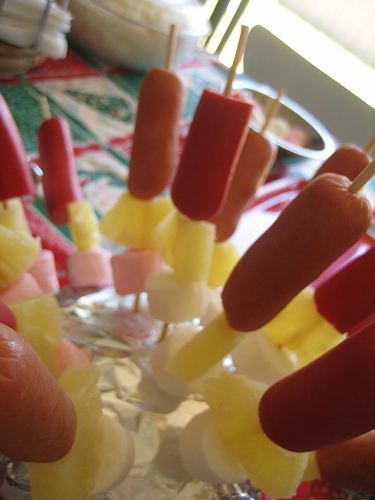<image>What is the origin of this appetizer? It is unknown what is the origin of this appetizer. It could be from 'tree pig confectionary', 'winnies', 'hawaii', 'shish kabob', 'kebab', or 'rocket ships'. What is the origin of this appetizer? The origin of this appetizer is unknown. It can be from various places such as tree pig confectionary, winnies, hawaii, shish kabob, kebab, or rocket ships. 